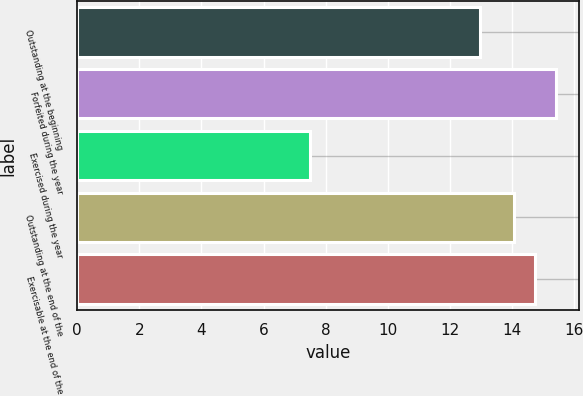<chart> <loc_0><loc_0><loc_500><loc_500><bar_chart><fcel>Outstanding at the beginning<fcel>Forfeited during the year<fcel>Exercised during the year<fcel>Outstanding at the end of the<fcel>Exercisable at the end of the<nl><fcel>12.97<fcel>15.4<fcel>7.5<fcel>14.06<fcel>14.73<nl></chart> 